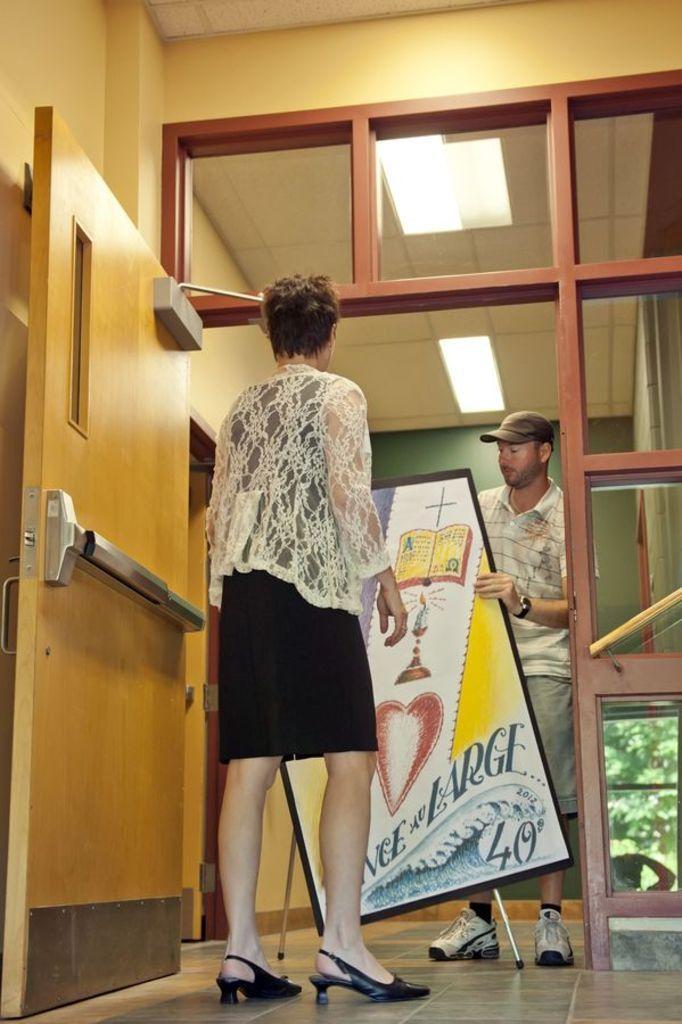Describe this image in one or two sentences. In this picture I can see a man and a woman standing man holding a board in his hand and I can see some pictures and text on the board and man variety cap on his head and a few lights to the ceiling and I can see reflection of a tree and a human in the glass. 